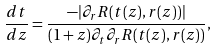Convert formula to latex. <formula><loc_0><loc_0><loc_500><loc_500>\frac { d t } { d z } = \frac { - | \partial _ { r } R ( t ( z ) , r ( z ) ) | } { ( 1 + z ) \partial _ { t } \partial _ { r } R ( t ( z ) , r ( z ) ) } ,</formula> 